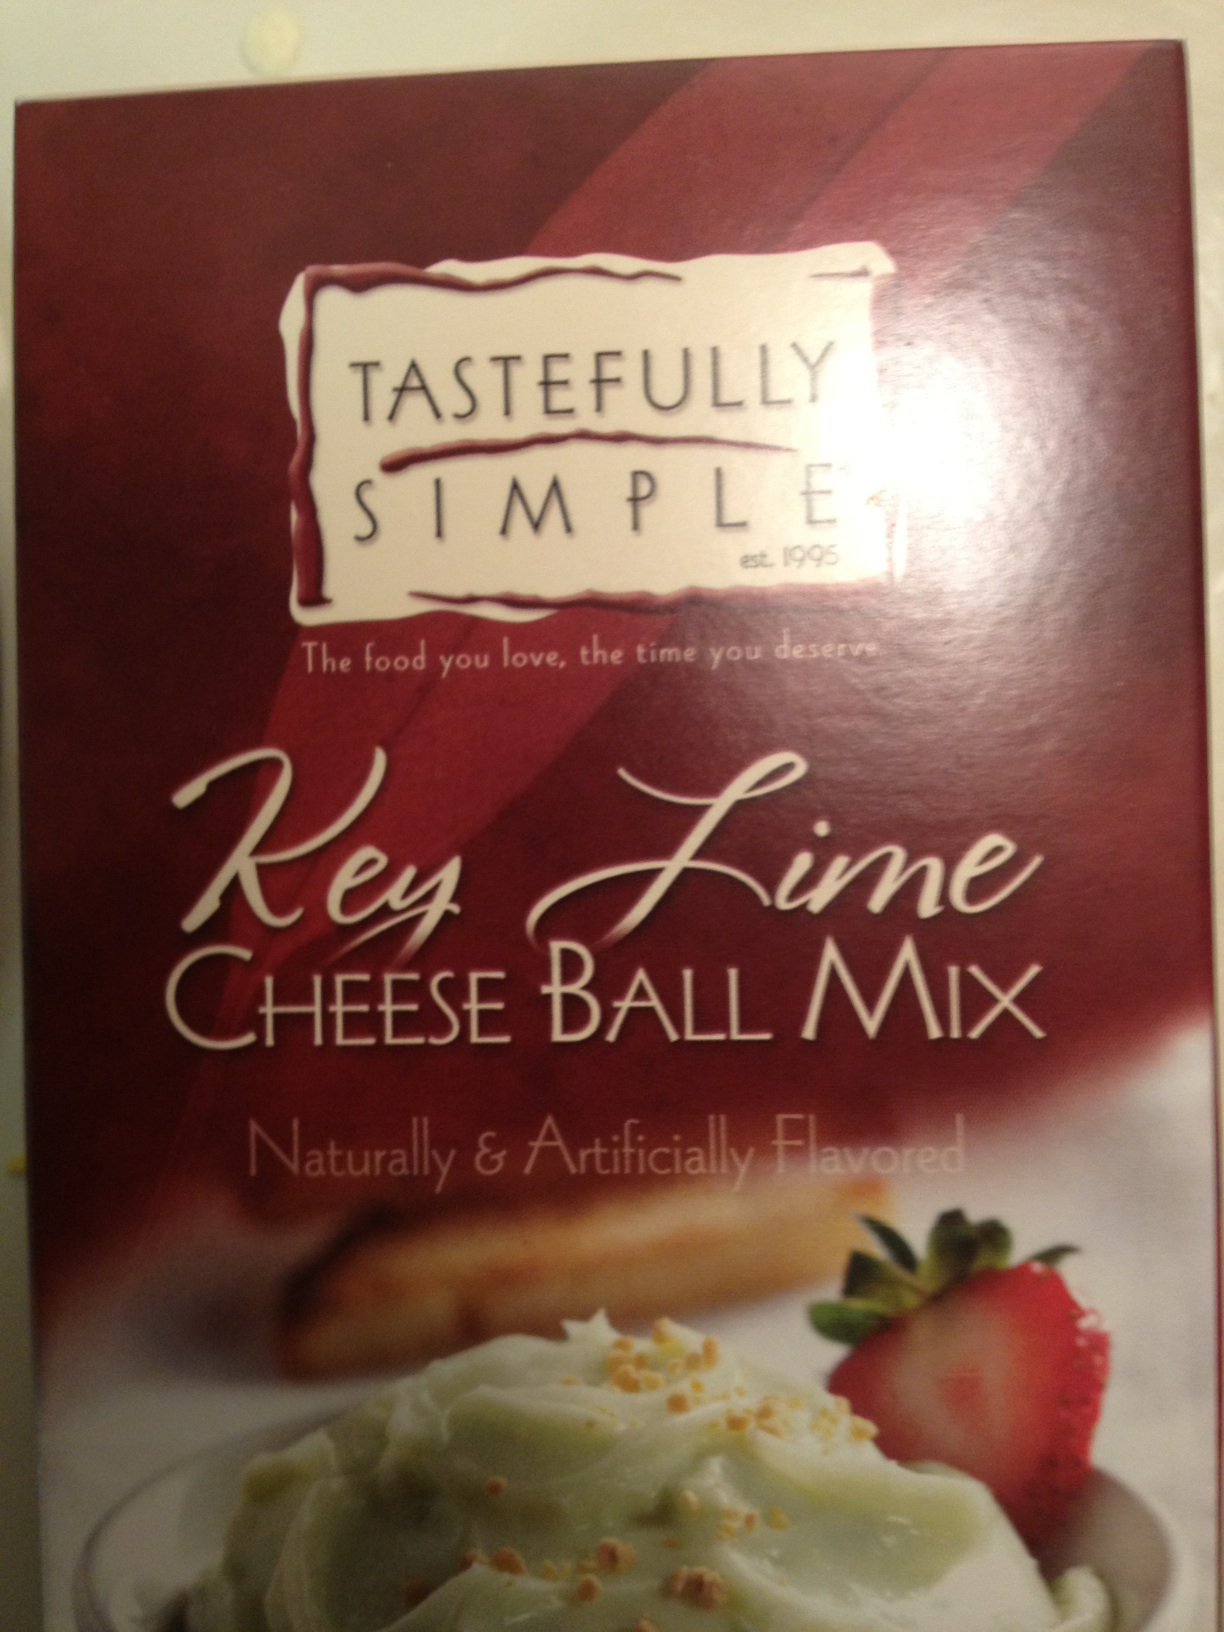What is this? This is a package of 'Key Lime Cheese Ball Mix', a product by Tastefully Simple. It is flavored both naturally and artificially and is designed to be a convenient mix for creating a dessert cheese ball, typically served with crackers or fruit like the strawberries depicted in the image. 